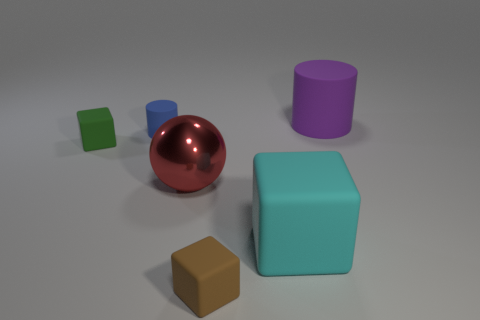Are there fewer tiny brown rubber cubes that are to the right of the big block than tiny brown cubes that are behind the purple object?
Your answer should be very brief. No. There is another big object that is the same shape as the green object; what is its color?
Offer a very short reply. Cyan. What number of big things are behind the green object and to the left of the brown block?
Give a very brief answer. 0. Are there more balls that are on the right side of the big purple rubber cylinder than small brown objects on the left side of the small blue cylinder?
Provide a succinct answer. No. What size is the brown matte thing?
Provide a succinct answer. Small. Is there a red object of the same shape as the small green rubber thing?
Offer a terse response. No. Do the small blue matte object and the small green thing that is on the left side of the tiny brown cube have the same shape?
Offer a very short reply. No. There is a rubber cube that is both on the right side of the small matte cylinder and on the left side of the cyan cube; how big is it?
Keep it short and to the point. Small. What number of purple rubber objects are there?
Keep it short and to the point. 1. What material is the cube that is the same size as the brown rubber thing?
Provide a succinct answer. Rubber. 